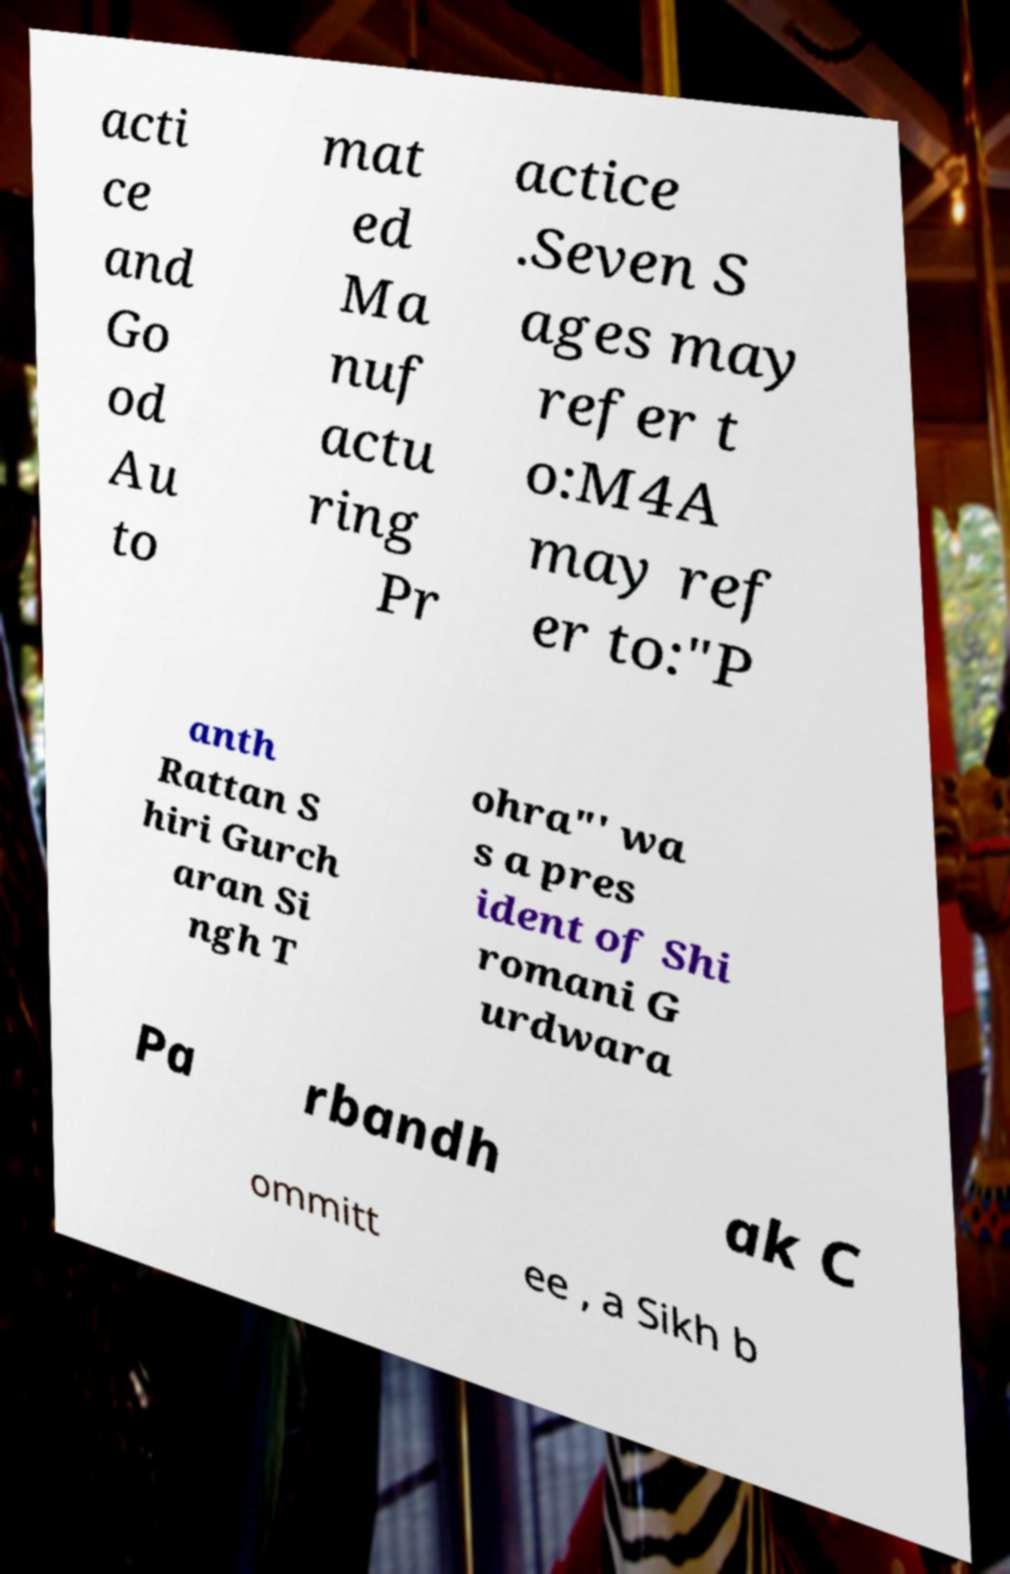Could you assist in decoding the text presented in this image and type it out clearly? acti ce and Go od Au to mat ed Ma nuf actu ring Pr actice .Seven S ages may refer t o:M4A may ref er to:"P anth Rattan S hiri Gurch aran Si ngh T ohra"' wa s a pres ident of Shi romani G urdwara Pa rbandh ak C ommitt ee , a Sikh b 